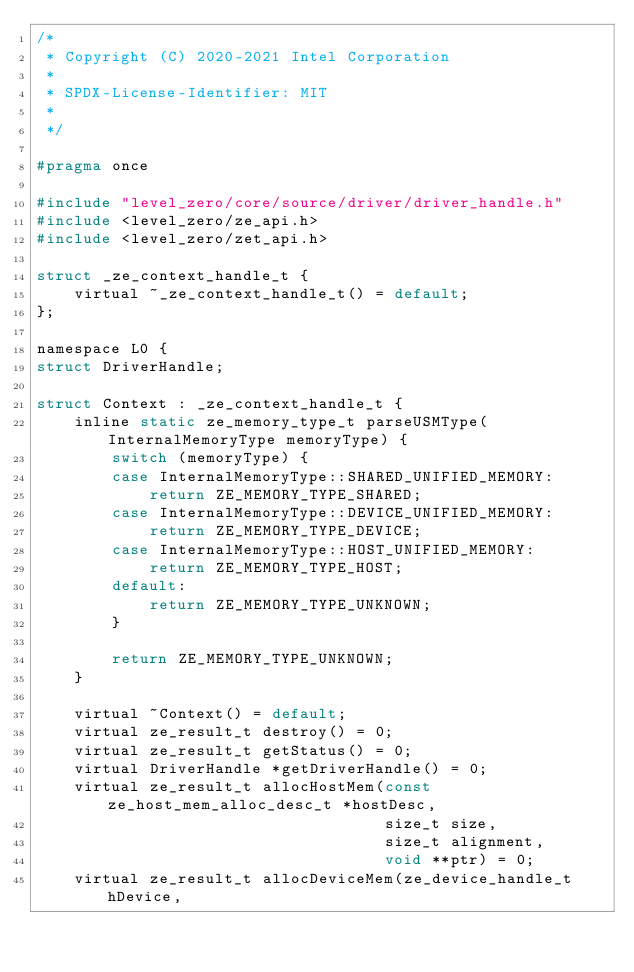<code> <loc_0><loc_0><loc_500><loc_500><_C_>/*
 * Copyright (C) 2020-2021 Intel Corporation
 *
 * SPDX-License-Identifier: MIT
 *
 */

#pragma once

#include "level_zero/core/source/driver/driver_handle.h"
#include <level_zero/ze_api.h>
#include <level_zero/zet_api.h>

struct _ze_context_handle_t {
    virtual ~_ze_context_handle_t() = default;
};

namespace L0 {
struct DriverHandle;

struct Context : _ze_context_handle_t {
    inline static ze_memory_type_t parseUSMType(InternalMemoryType memoryType) {
        switch (memoryType) {
        case InternalMemoryType::SHARED_UNIFIED_MEMORY:
            return ZE_MEMORY_TYPE_SHARED;
        case InternalMemoryType::DEVICE_UNIFIED_MEMORY:
            return ZE_MEMORY_TYPE_DEVICE;
        case InternalMemoryType::HOST_UNIFIED_MEMORY:
            return ZE_MEMORY_TYPE_HOST;
        default:
            return ZE_MEMORY_TYPE_UNKNOWN;
        }

        return ZE_MEMORY_TYPE_UNKNOWN;
    }

    virtual ~Context() = default;
    virtual ze_result_t destroy() = 0;
    virtual ze_result_t getStatus() = 0;
    virtual DriverHandle *getDriverHandle() = 0;
    virtual ze_result_t allocHostMem(const ze_host_mem_alloc_desc_t *hostDesc,
                                     size_t size,
                                     size_t alignment,
                                     void **ptr) = 0;
    virtual ze_result_t allocDeviceMem(ze_device_handle_t hDevice,</code> 